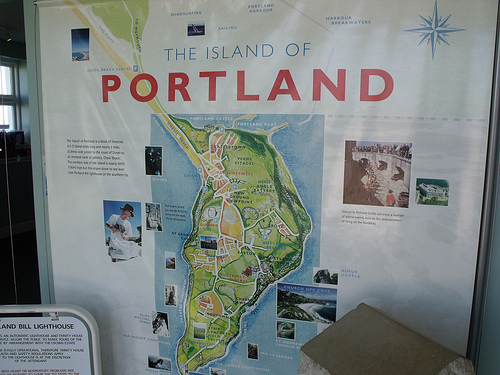<image>
Is there a compass rose next to the map? Yes. The compass rose is positioned adjacent to the map, located nearby in the same general area. 